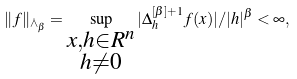Convert formula to latex. <formula><loc_0><loc_0><loc_500><loc_500>\| f \| _ { \dot { \land } _ { \beta } } = \sup _ { \substack { x , h \in R ^ { n } \\ h \ne 0 } } | \Delta _ { h } ^ { [ \beta ] + 1 } f ( x ) | / | h | ^ { \beta } < \infty ,</formula> 